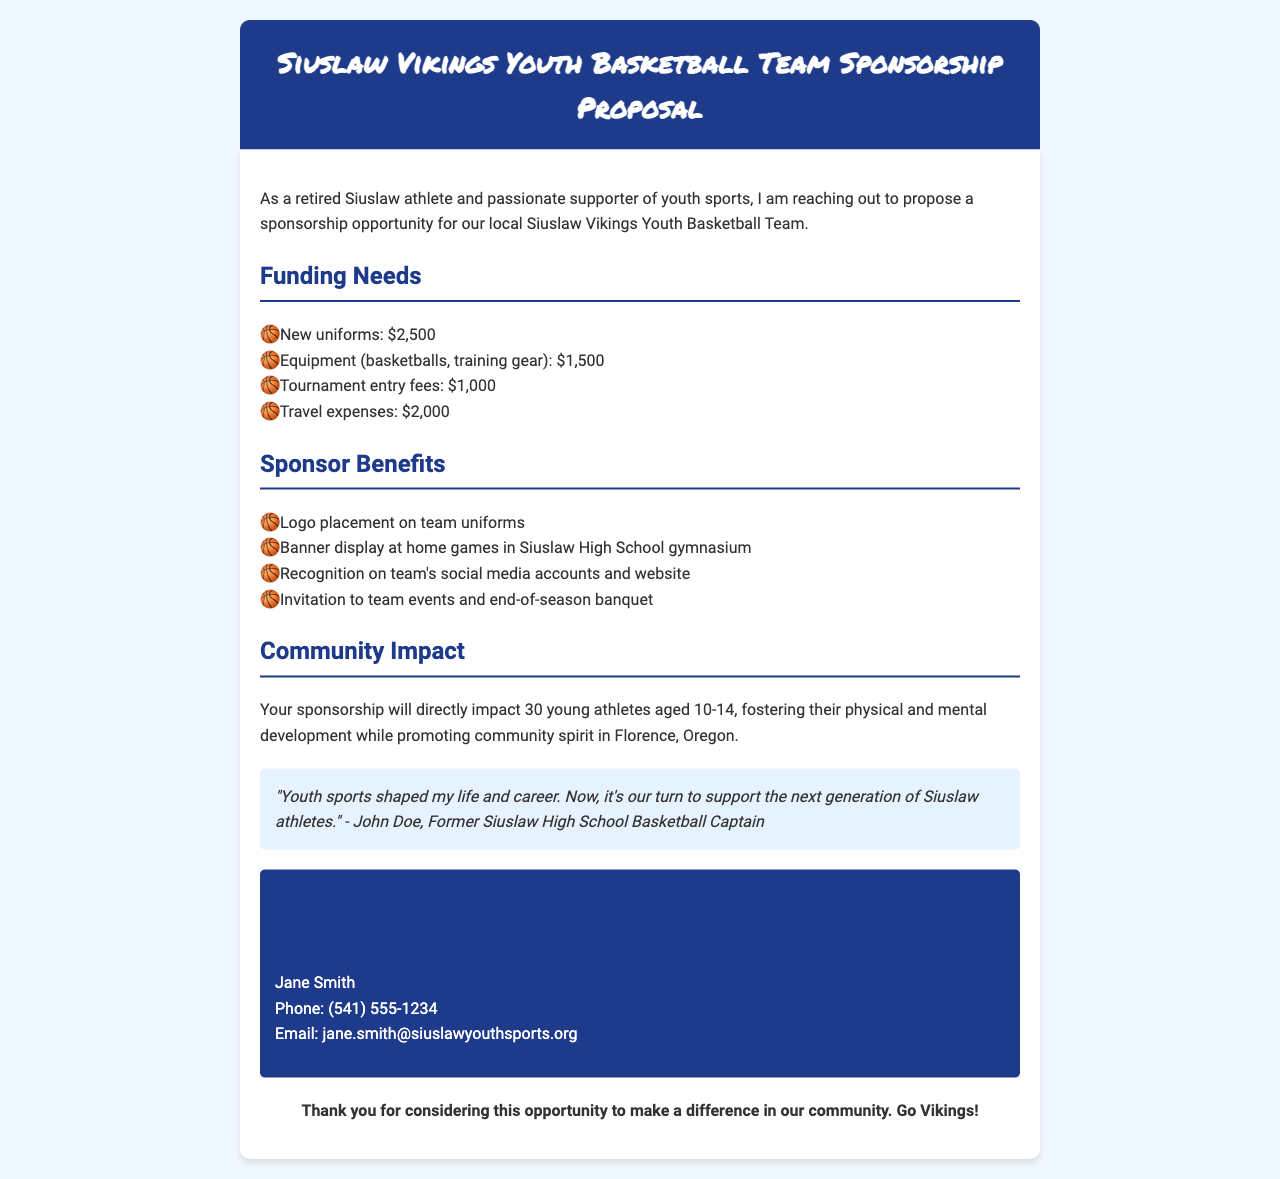What is the total funding needed? The total funding needed is the sum of all individual funding needs listed in the document: $2,500 + $1,500 + $1,000 + $2,000 = $7,000.
Answer: $7,000 Who is the contact person for sponsorship inquiries? The document mentions Jane Smith as the contact person for sponsorship inquiries.
Answer: Jane Smith What age group do the athletes belong to? The document states that the athletes are aged 10-14 years old.
Answer: 10-14 What is one of the sponsor benefits listed in the document? One of the benefits mentioned is logo placement on team uniforms.
Answer: Logo placement on team uniforms How many young athletes does the sponsorship impact? The document indicates that the sponsorship will directly impact 30 young athletes.
Answer: 30 What is the travel expense amount detailed in the proposal? The travel expenses listed in the funding needs is $2,000.
Answer: $2,000 What is the name of the youth sports team? The document mentions the name of the team as Siuslaw Vikings Youth Basketball Team.
Answer: Siuslaw Vikings Youth Basketball Team What type of document is this? The document is a sponsorship proposal.
Answer: Sponsorship proposal What is the quote about youth sports in the document attributed to? The quote about youth sports is attributed to John Doe.
Answer: John Doe 